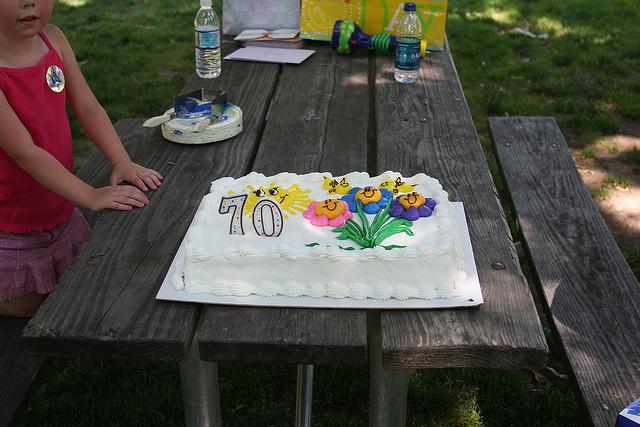Which birthday is being celebrated?
Write a very short answer. 70. Will the number on the birthday cake denote the person's age?
Short answer required. Yes. Are the flowers on the cake real?
Answer briefly. No. 